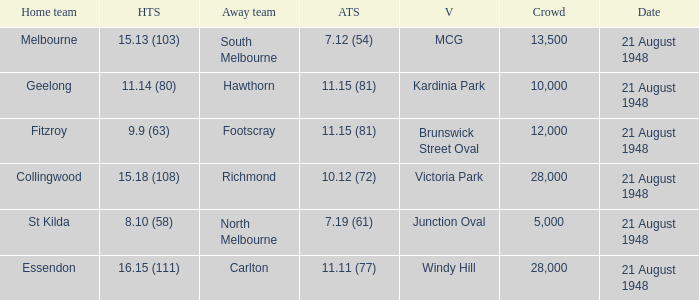When the Home team score was 15.18 (108), what's the lowest Crowd turnout? 28000.0. 